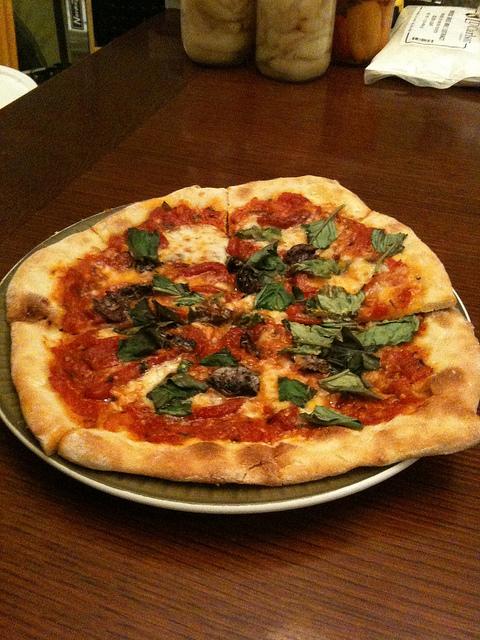What toppings are on the pizza?
Keep it brief. Spinach. What is the pizza on?
Write a very short answer. Plate. What color is the table?
Short answer required. Brown. Are any slices missing?
Answer briefly. No. 